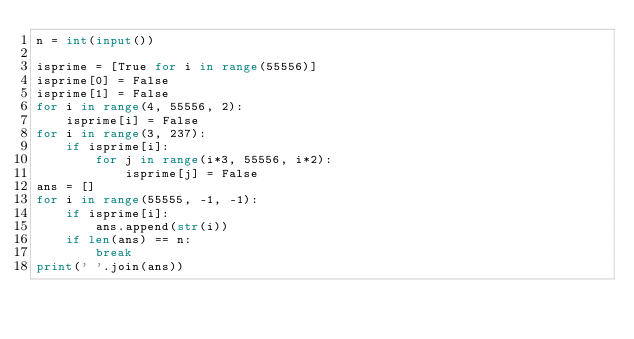Convert code to text. <code><loc_0><loc_0><loc_500><loc_500><_Python_>n = int(input())

isprime = [True for i in range(55556)]
isprime[0] = False
isprime[1] = False
for i in range(4, 55556, 2):
    isprime[i] = False
for i in range(3, 237):
    if isprime[i]:
        for j in range(i*3, 55556, i*2):
            isprime[j] = False
ans = []
for i in range(55555, -1, -1):
    if isprime[i]:
        ans.append(str(i))
    if len(ans) == n:
        break
print(' '.join(ans))</code> 